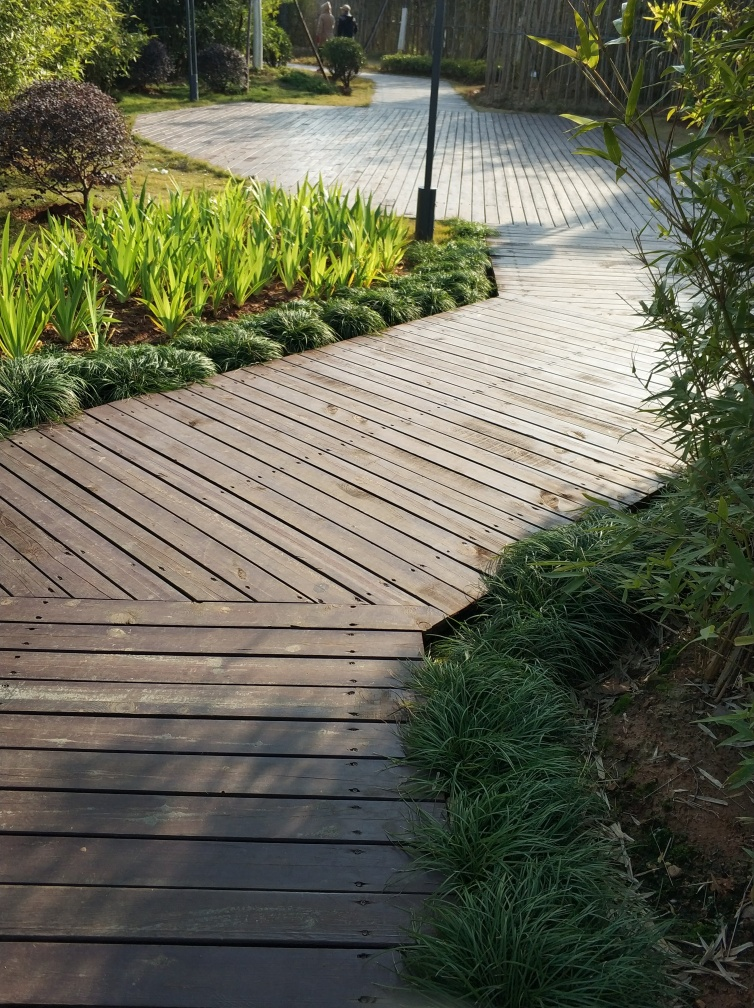What time of day does this image appear to capture? The long shadows and the warm, golden light suggest this image was likely taken during the late afternoon, a few hours before sunset. 